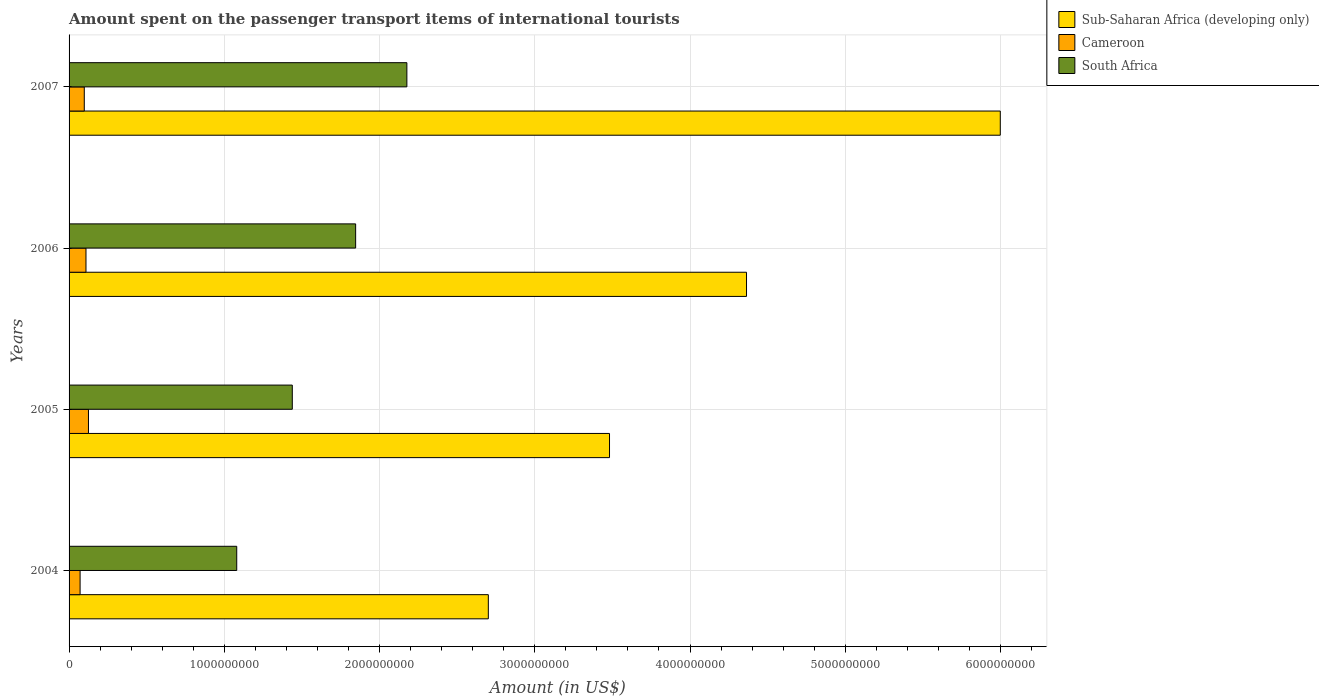How many different coloured bars are there?
Your answer should be very brief. 3. How many groups of bars are there?
Provide a succinct answer. 4. Are the number of bars per tick equal to the number of legend labels?
Your answer should be compact. Yes. How many bars are there on the 4th tick from the top?
Make the answer very short. 3. How many bars are there on the 2nd tick from the bottom?
Your response must be concise. 3. What is the label of the 4th group of bars from the top?
Your answer should be compact. 2004. In how many cases, is the number of bars for a given year not equal to the number of legend labels?
Your answer should be compact. 0. What is the amount spent on the passenger transport items of international tourists in Sub-Saharan Africa (developing only) in 2004?
Give a very brief answer. 2.70e+09. Across all years, what is the maximum amount spent on the passenger transport items of international tourists in Cameroon?
Give a very brief answer. 1.25e+08. Across all years, what is the minimum amount spent on the passenger transport items of international tourists in Sub-Saharan Africa (developing only)?
Ensure brevity in your answer.  2.70e+09. In which year was the amount spent on the passenger transport items of international tourists in Sub-Saharan Africa (developing only) minimum?
Make the answer very short. 2004. What is the total amount spent on the passenger transport items of international tourists in South Africa in the graph?
Give a very brief answer. 6.54e+09. What is the difference between the amount spent on the passenger transport items of international tourists in Sub-Saharan Africa (developing only) in 2006 and that in 2007?
Keep it short and to the point. -1.63e+09. What is the difference between the amount spent on the passenger transport items of international tourists in Cameroon in 2004 and the amount spent on the passenger transport items of international tourists in Sub-Saharan Africa (developing only) in 2006?
Give a very brief answer. -4.29e+09. What is the average amount spent on the passenger transport items of international tourists in Sub-Saharan Africa (developing only) per year?
Your answer should be compact. 4.14e+09. In the year 2005, what is the difference between the amount spent on the passenger transport items of international tourists in Sub-Saharan Africa (developing only) and amount spent on the passenger transport items of international tourists in Cameroon?
Provide a short and direct response. 3.36e+09. In how many years, is the amount spent on the passenger transport items of international tourists in Cameroon greater than 6000000000 US$?
Your answer should be very brief. 0. What is the ratio of the amount spent on the passenger transport items of international tourists in Sub-Saharan Africa (developing only) in 2004 to that in 2005?
Offer a very short reply. 0.78. Is the amount spent on the passenger transport items of international tourists in Cameroon in 2006 less than that in 2007?
Offer a very short reply. No. What is the difference between the highest and the second highest amount spent on the passenger transport items of international tourists in Cameroon?
Keep it short and to the point. 1.60e+07. What is the difference between the highest and the lowest amount spent on the passenger transport items of international tourists in Sub-Saharan Africa (developing only)?
Offer a terse response. 3.30e+09. Is the sum of the amount spent on the passenger transport items of international tourists in South Africa in 2004 and 2005 greater than the maximum amount spent on the passenger transport items of international tourists in Cameroon across all years?
Offer a very short reply. Yes. What does the 2nd bar from the top in 2004 represents?
Ensure brevity in your answer.  Cameroon. What does the 2nd bar from the bottom in 2006 represents?
Offer a terse response. Cameroon. How many bars are there?
Make the answer very short. 12. Are all the bars in the graph horizontal?
Make the answer very short. Yes. What is the difference between two consecutive major ticks on the X-axis?
Make the answer very short. 1.00e+09. Does the graph contain any zero values?
Give a very brief answer. No. Does the graph contain grids?
Give a very brief answer. Yes. Where does the legend appear in the graph?
Make the answer very short. Top right. What is the title of the graph?
Your answer should be very brief. Amount spent on the passenger transport items of international tourists. Does "Virgin Islands" appear as one of the legend labels in the graph?
Your answer should be very brief. No. What is the Amount (in US$) of Sub-Saharan Africa (developing only) in 2004?
Provide a short and direct response. 2.70e+09. What is the Amount (in US$) in Cameroon in 2004?
Provide a short and direct response. 7.10e+07. What is the Amount (in US$) of South Africa in 2004?
Give a very brief answer. 1.08e+09. What is the Amount (in US$) of Sub-Saharan Africa (developing only) in 2005?
Offer a terse response. 3.48e+09. What is the Amount (in US$) of Cameroon in 2005?
Keep it short and to the point. 1.25e+08. What is the Amount (in US$) of South Africa in 2005?
Make the answer very short. 1.44e+09. What is the Amount (in US$) in Sub-Saharan Africa (developing only) in 2006?
Offer a very short reply. 4.36e+09. What is the Amount (in US$) in Cameroon in 2006?
Your answer should be very brief. 1.09e+08. What is the Amount (in US$) of South Africa in 2006?
Offer a terse response. 1.85e+09. What is the Amount (in US$) in Sub-Saharan Africa (developing only) in 2007?
Your response must be concise. 6.00e+09. What is the Amount (in US$) of Cameroon in 2007?
Provide a short and direct response. 9.80e+07. What is the Amount (in US$) of South Africa in 2007?
Make the answer very short. 2.18e+09. Across all years, what is the maximum Amount (in US$) of Sub-Saharan Africa (developing only)?
Provide a succinct answer. 6.00e+09. Across all years, what is the maximum Amount (in US$) in Cameroon?
Give a very brief answer. 1.25e+08. Across all years, what is the maximum Amount (in US$) in South Africa?
Offer a terse response. 2.18e+09. Across all years, what is the minimum Amount (in US$) of Sub-Saharan Africa (developing only)?
Ensure brevity in your answer.  2.70e+09. Across all years, what is the minimum Amount (in US$) in Cameroon?
Provide a short and direct response. 7.10e+07. Across all years, what is the minimum Amount (in US$) of South Africa?
Offer a very short reply. 1.08e+09. What is the total Amount (in US$) of Sub-Saharan Africa (developing only) in the graph?
Your answer should be compact. 1.65e+1. What is the total Amount (in US$) in Cameroon in the graph?
Your response must be concise. 4.03e+08. What is the total Amount (in US$) of South Africa in the graph?
Offer a very short reply. 6.54e+09. What is the difference between the Amount (in US$) in Sub-Saharan Africa (developing only) in 2004 and that in 2005?
Your answer should be very brief. -7.81e+08. What is the difference between the Amount (in US$) in Cameroon in 2004 and that in 2005?
Give a very brief answer. -5.40e+07. What is the difference between the Amount (in US$) of South Africa in 2004 and that in 2005?
Give a very brief answer. -3.58e+08. What is the difference between the Amount (in US$) of Sub-Saharan Africa (developing only) in 2004 and that in 2006?
Give a very brief answer. -1.66e+09. What is the difference between the Amount (in US$) of Cameroon in 2004 and that in 2006?
Keep it short and to the point. -3.80e+07. What is the difference between the Amount (in US$) in South Africa in 2004 and that in 2006?
Keep it short and to the point. -7.66e+08. What is the difference between the Amount (in US$) of Sub-Saharan Africa (developing only) in 2004 and that in 2007?
Offer a terse response. -3.30e+09. What is the difference between the Amount (in US$) in Cameroon in 2004 and that in 2007?
Make the answer very short. -2.70e+07. What is the difference between the Amount (in US$) in South Africa in 2004 and that in 2007?
Offer a terse response. -1.10e+09. What is the difference between the Amount (in US$) of Sub-Saharan Africa (developing only) in 2005 and that in 2006?
Ensure brevity in your answer.  -8.83e+08. What is the difference between the Amount (in US$) in Cameroon in 2005 and that in 2006?
Offer a very short reply. 1.60e+07. What is the difference between the Amount (in US$) of South Africa in 2005 and that in 2006?
Your response must be concise. -4.08e+08. What is the difference between the Amount (in US$) of Sub-Saharan Africa (developing only) in 2005 and that in 2007?
Your response must be concise. -2.52e+09. What is the difference between the Amount (in US$) in Cameroon in 2005 and that in 2007?
Ensure brevity in your answer.  2.70e+07. What is the difference between the Amount (in US$) of South Africa in 2005 and that in 2007?
Ensure brevity in your answer.  -7.38e+08. What is the difference between the Amount (in US$) of Sub-Saharan Africa (developing only) in 2006 and that in 2007?
Give a very brief answer. -1.63e+09. What is the difference between the Amount (in US$) in Cameroon in 2006 and that in 2007?
Your answer should be very brief. 1.10e+07. What is the difference between the Amount (in US$) of South Africa in 2006 and that in 2007?
Your answer should be compact. -3.30e+08. What is the difference between the Amount (in US$) of Sub-Saharan Africa (developing only) in 2004 and the Amount (in US$) of Cameroon in 2005?
Offer a terse response. 2.58e+09. What is the difference between the Amount (in US$) in Sub-Saharan Africa (developing only) in 2004 and the Amount (in US$) in South Africa in 2005?
Ensure brevity in your answer.  1.26e+09. What is the difference between the Amount (in US$) of Cameroon in 2004 and the Amount (in US$) of South Africa in 2005?
Make the answer very short. -1.37e+09. What is the difference between the Amount (in US$) of Sub-Saharan Africa (developing only) in 2004 and the Amount (in US$) of Cameroon in 2006?
Your answer should be very brief. 2.59e+09. What is the difference between the Amount (in US$) in Sub-Saharan Africa (developing only) in 2004 and the Amount (in US$) in South Africa in 2006?
Give a very brief answer. 8.55e+08. What is the difference between the Amount (in US$) in Cameroon in 2004 and the Amount (in US$) in South Africa in 2006?
Your answer should be compact. -1.78e+09. What is the difference between the Amount (in US$) of Sub-Saharan Africa (developing only) in 2004 and the Amount (in US$) of Cameroon in 2007?
Ensure brevity in your answer.  2.60e+09. What is the difference between the Amount (in US$) in Sub-Saharan Africa (developing only) in 2004 and the Amount (in US$) in South Africa in 2007?
Your answer should be compact. 5.25e+08. What is the difference between the Amount (in US$) in Cameroon in 2004 and the Amount (in US$) in South Africa in 2007?
Keep it short and to the point. -2.10e+09. What is the difference between the Amount (in US$) of Sub-Saharan Africa (developing only) in 2005 and the Amount (in US$) of Cameroon in 2006?
Your answer should be very brief. 3.37e+09. What is the difference between the Amount (in US$) in Sub-Saharan Africa (developing only) in 2005 and the Amount (in US$) in South Africa in 2006?
Keep it short and to the point. 1.64e+09. What is the difference between the Amount (in US$) in Cameroon in 2005 and the Amount (in US$) in South Africa in 2006?
Provide a succinct answer. -1.72e+09. What is the difference between the Amount (in US$) in Sub-Saharan Africa (developing only) in 2005 and the Amount (in US$) in Cameroon in 2007?
Your answer should be compact. 3.38e+09. What is the difference between the Amount (in US$) in Sub-Saharan Africa (developing only) in 2005 and the Amount (in US$) in South Africa in 2007?
Your answer should be compact. 1.31e+09. What is the difference between the Amount (in US$) of Cameroon in 2005 and the Amount (in US$) of South Africa in 2007?
Provide a short and direct response. -2.05e+09. What is the difference between the Amount (in US$) of Sub-Saharan Africa (developing only) in 2006 and the Amount (in US$) of Cameroon in 2007?
Your answer should be compact. 4.27e+09. What is the difference between the Amount (in US$) of Sub-Saharan Africa (developing only) in 2006 and the Amount (in US$) of South Africa in 2007?
Offer a very short reply. 2.19e+09. What is the difference between the Amount (in US$) of Cameroon in 2006 and the Amount (in US$) of South Africa in 2007?
Offer a terse response. -2.07e+09. What is the average Amount (in US$) of Sub-Saharan Africa (developing only) per year?
Provide a succinct answer. 4.14e+09. What is the average Amount (in US$) of Cameroon per year?
Provide a succinct answer. 1.01e+08. What is the average Amount (in US$) of South Africa per year?
Your answer should be very brief. 1.64e+09. In the year 2004, what is the difference between the Amount (in US$) in Sub-Saharan Africa (developing only) and Amount (in US$) in Cameroon?
Your response must be concise. 2.63e+09. In the year 2004, what is the difference between the Amount (in US$) in Sub-Saharan Africa (developing only) and Amount (in US$) in South Africa?
Ensure brevity in your answer.  1.62e+09. In the year 2004, what is the difference between the Amount (in US$) of Cameroon and Amount (in US$) of South Africa?
Give a very brief answer. -1.01e+09. In the year 2005, what is the difference between the Amount (in US$) of Sub-Saharan Africa (developing only) and Amount (in US$) of Cameroon?
Offer a terse response. 3.36e+09. In the year 2005, what is the difference between the Amount (in US$) of Sub-Saharan Africa (developing only) and Amount (in US$) of South Africa?
Your response must be concise. 2.04e+09. In the year 2005, what is the difference between the Amount (in US$) in Cameroon and Amount (in US$) in South Africa?
Offer a terse response. -1.31e+09. In the year 2006, what is the difference between the Amount (in US$) in Sub-Saharan Africa (developing only) and Amount (in US$) in Cameroon?
Ensure brevity in your answer.  4.25e+09. In the year 2006, what is the difference between the Amount (in US$) of Sub-Saharan Africa (developing only) and Amount (in US$) of South Africa?
Make the answer very short. 2.52e+09. In the year 2006, what is the difference between the Amount (in US$) in Cameroon and Amount (in US$) in South Africa?
Provide a short and direct response. -1.74e+09. In the year 2007, what is the difference between the Amount (in US$) of Sub-Saharan Africa (developing only) and Amount (in US$) of Cameroon?
Your answer should be very brief. 5.90e+09. In the year 2007, what is the difference between the Amount (in US$) of Sub-Saharan Africa (developing only) and Amount (in US$) of South Africa?
Offer a terse response. 3.82e+09. In the year 2007, what is the difference between the Amount (in US$) of Cameroon and Amount (in US$) of South Africa?
Keep it short and to the point. -2.08e+09. What is the ratio of the Amount (in US$) in Sub-Saharan Africa (developing only) in 2004 to that in 2005?
Ensure brevity in your answer.  0.78. What is the ratio of the Amount (in US$) in Cameroon in 2004 to that in 2005?
Offer a very short reply. 0.57. What is the ratio of the Amount (in US$) of South Africa in 2004 to that in 2005?
Your answer should be compact. 0.75. What is the ratio of the Amount (in US$) in Sub-Saharan Africa (developing only) in 2004 to that in 2006?
Provide a short and direct response. 0.62. What is the ratio of the Amount (in US$) of Cameroon in 2004 to that in 2006?
Offer a very short reply. 0.65. What is the ratio of the Amount (in US$) in South Africa in 2004 to that in 2006?
Offer a terse response. 0.58. What is the ratio of the Amount (in US$) in Sub-Saharan Africa (developing only) in 2004 to that in 2007?
Provide a succinct answer. 0.45. What is the ratio of the Amount (in US$) of Cameroon in 2004 to that in 2007?
Keep it short and to the point. 0.72. What is the ratio of the Amount (in US$) of South Africa in 2004 to that in 2007?
Your answer should be very brief. 0.5. What is the ratio of the Amount (in US$) in Sub-Saharan Africa (developing only) in 2005 to that in 2006?
Give a very brief answer. 0.8. What is the ratio of the Amount (in US$) of Cameroon in 2005 to that in 2006?
Provide a succinct answer. 1.15. What is the ratio of the Amount (in US$) in South Africa in 2005 to that in 2006?
Your answer should be compact. 0.78. What is the ratio of the Amount (in US$) in Sub-Saharan Africa (developing only) in 2005 to that in 2007?
Offer a very short reply. 0.58. What is the ratio of the Amount (in US$) of Cameroon in 2005 to that in 2007?
Provide a succinct answer. 1.28. What is the ratio of the Amount (in US$) in South Africa in 2005 to that in 2007?
Offer a very short reply. 0.66. What is the ratio of the Amount (in US$) of Sub-Saharan Africa (developing only) in 2006 to that in 2007?
Your response must be concise. 0.73. What is the ratio of the Amount (in US$) in Cameroon in 2006 to that in 2007?
Provide a succinct answer. 1.11. What is the ratio of the Amount (in US$) of South Africa in 2006 to that in 2007?
Keep it short and to the point. 0.85. What is the difference between the highest and the second highest Amount (in US$) of Sub-Saharan Africa (developing only)?
Your answer should be compact. 1.63e+09. What is the difference between the highest and the second highest Amount (in US$) in Cameroon?
Ensure brevity in your answer.  1.60e+07. What is the difference between the highest and the second highest Amount (in US$) in South Africa?
Make the answer very short. 3.30e+08. What is the difference between the highest and the lowest Amount (in US$) in Sub-Saharan Africa (developing only)?
Give a very brief answer. 3.30e+09. What is the difference between the highest and the lowest Amount (in US$) in Cameroon?
Make the answer very short. 5.40e+07. What is the difference between the highest and the lowest Amount (in US$) of South Africa?
Provide a short and direct response. 1.10e+09. 